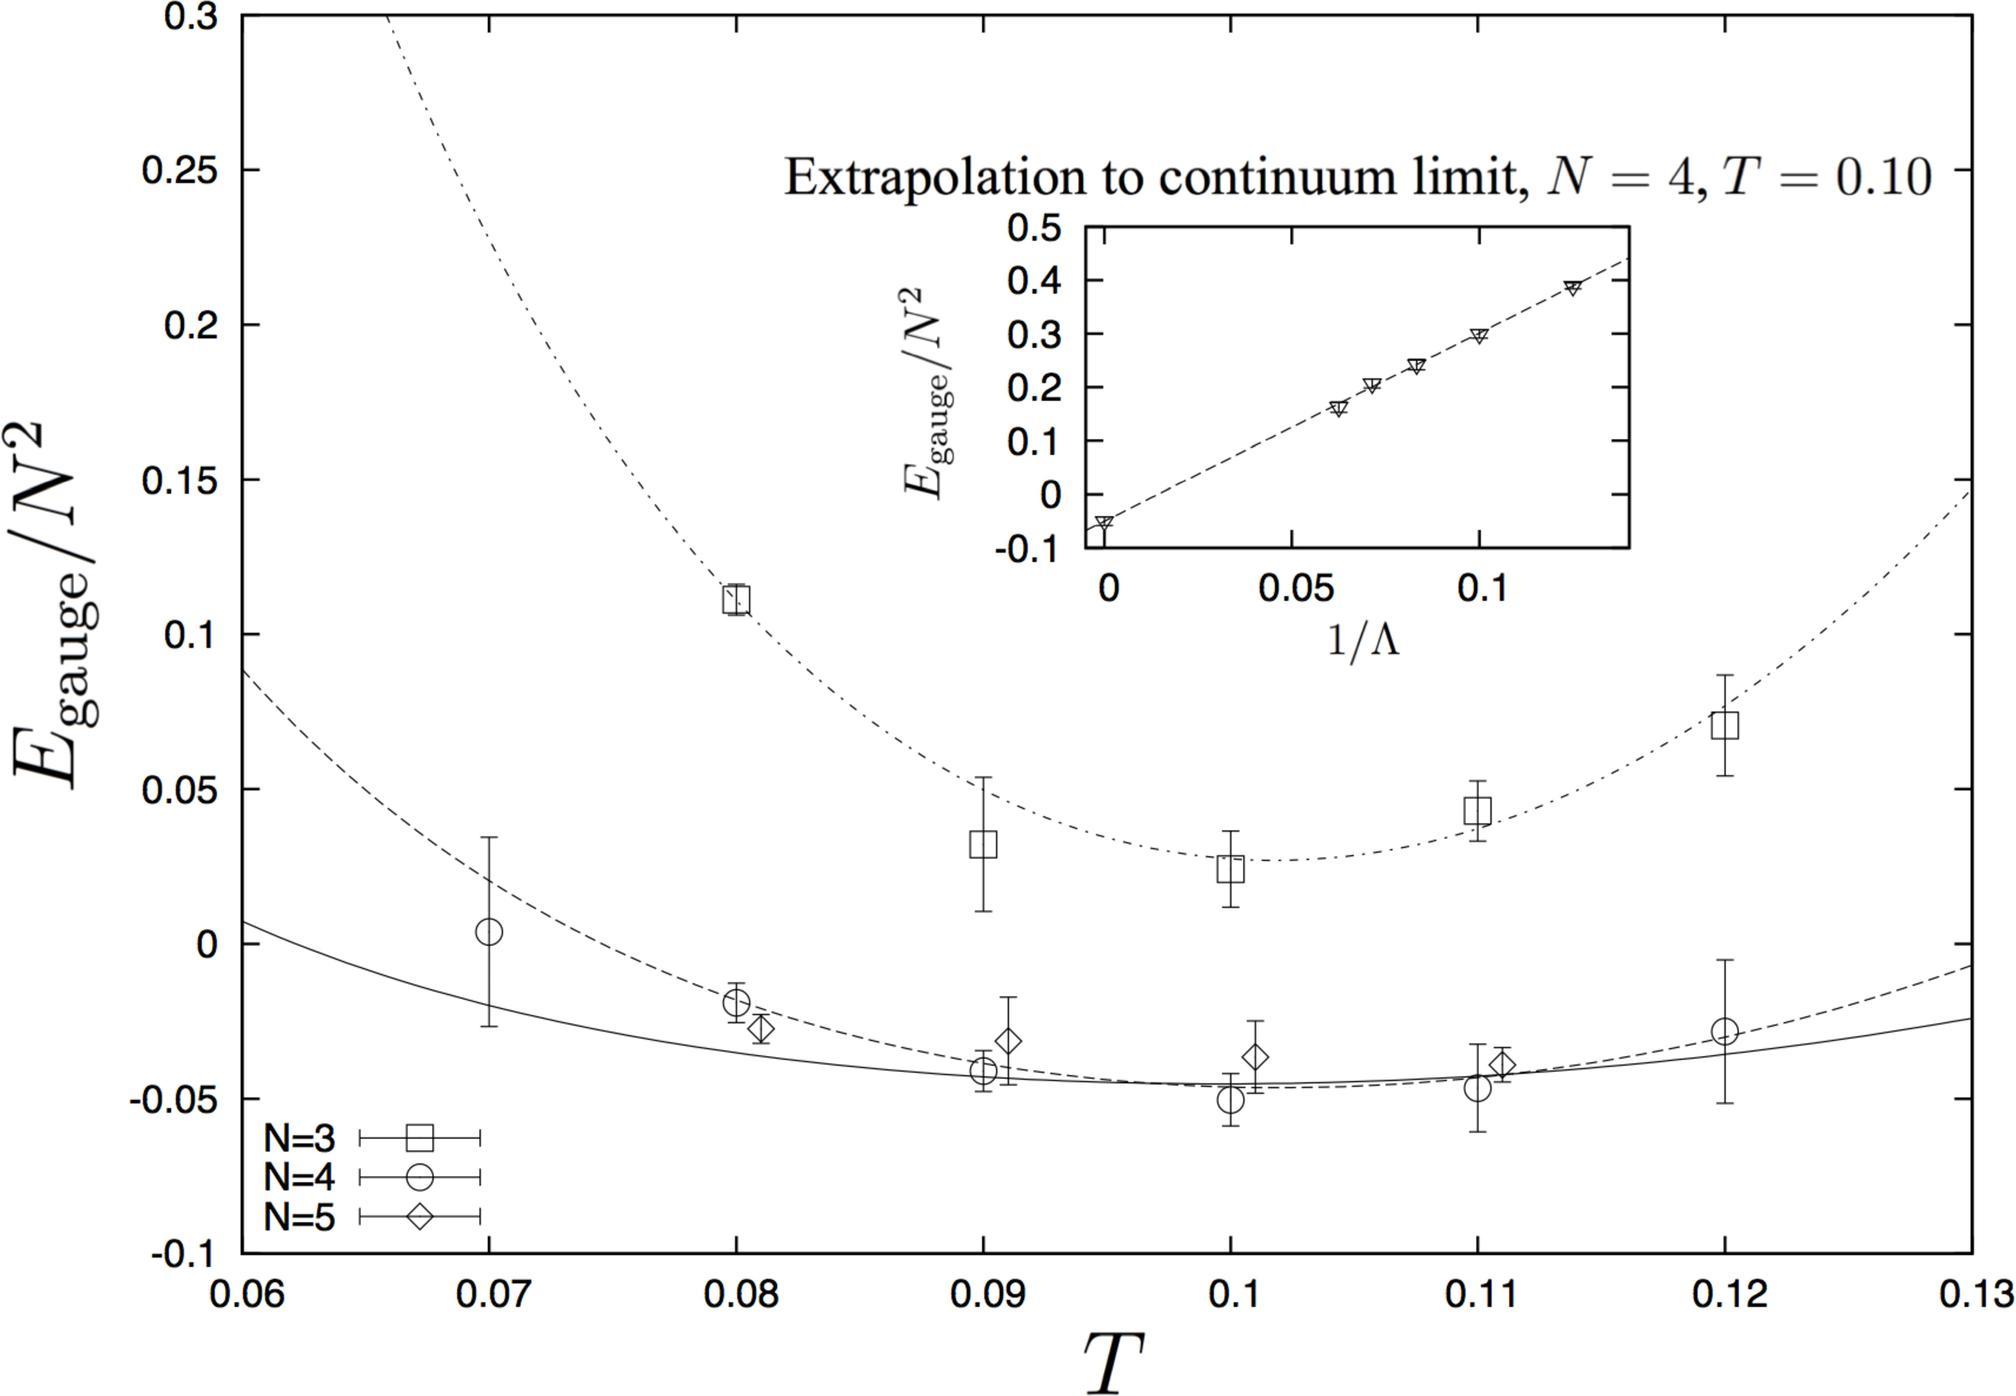What role does the temperature play in this graph? Temperature (T) is a critical factor in this graph as it directly influences the gauge energy, E_gauge. As T varies, we can observe how the gauge energy behaves under different thermal conditions. This is vital for understanding the thermal dynamics of the system in theoretical physics, particularly in studying phase transitions or related phenomena in gauge theories. 